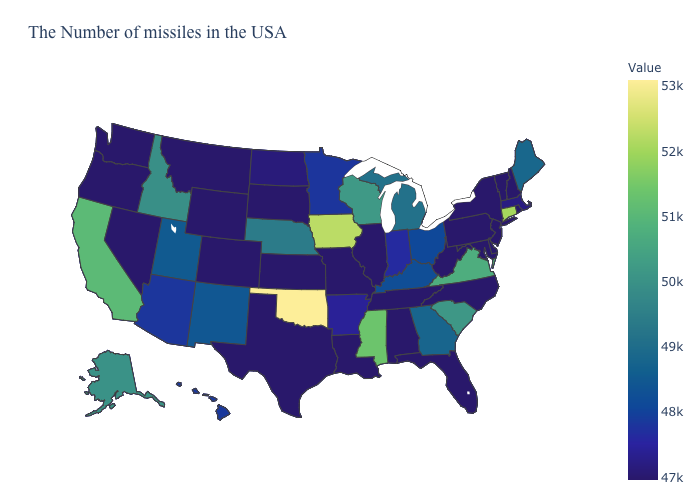Which states hav the highest value in the MidWest?
Concise answer only. Iowa. Does Tennessee have the lowest value in the USA?
Short answer required. Yes. Among the states that border Arkansas , which have the highest value?
Concise answer only. Oklahoma. Which states have the highest value in the USA?
Be succinct. Oklahoma. Which states hav the highest value in the Northeast?
Quick response, please. Connecticut. 